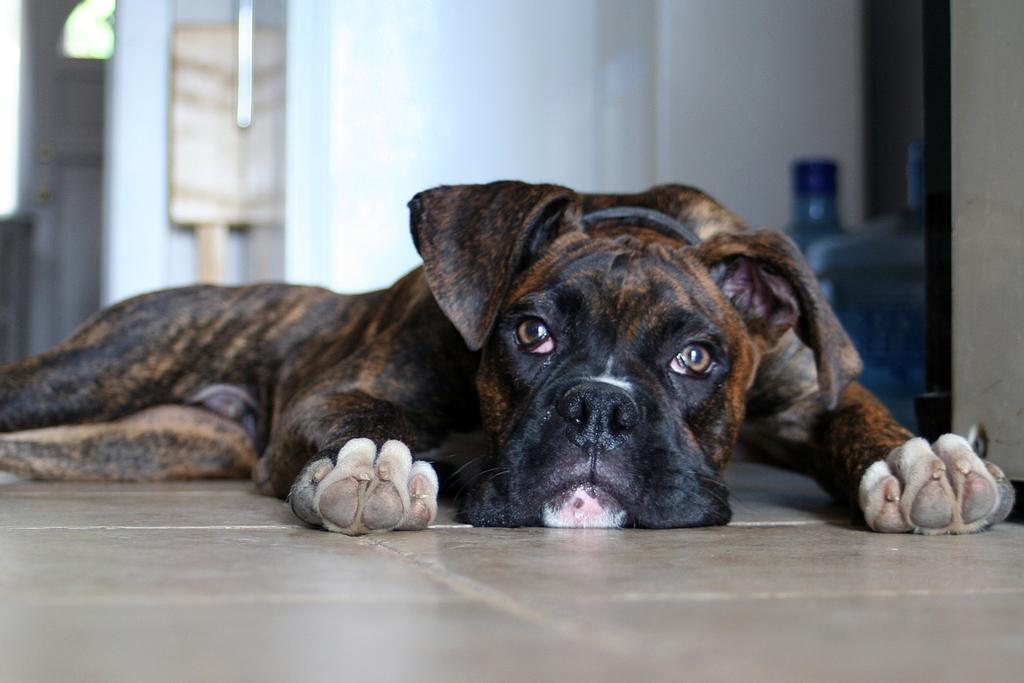What type of animal is in the image? There is a dog in the image. Where is the dog located? The dog is on the ground. What can be seen in the background of the image? There is a wall and water cans in the background of the image. Are there any other objects visible in the background? Yes, there are other objects visible in the background. What type of leather is the ghost wearing in the image? There is no ghost or leather present in the image; it features a dog on the ground with a wall and water cans in the background. 